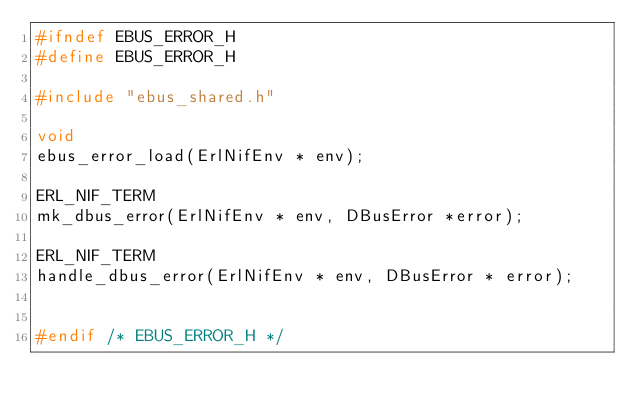<code> <loc_0><loc_0><loc_500><loc_500><_C_>#ifndef EBUS_ERROR_H
#define EBUS_ERROR_H

#include "ebus_shared.h"

void
ebus_error_load(ErlNifEnv * env);

ERL_NIF_TERM
mk_dbus_error(ErlNifEnv * env, DBusError *error);

ERL_NIF_TERM
handle_dbus_error(ErlNifEnv * env, DBusError * error);


#endif /* EBUS_ERROR_H */
</code> 